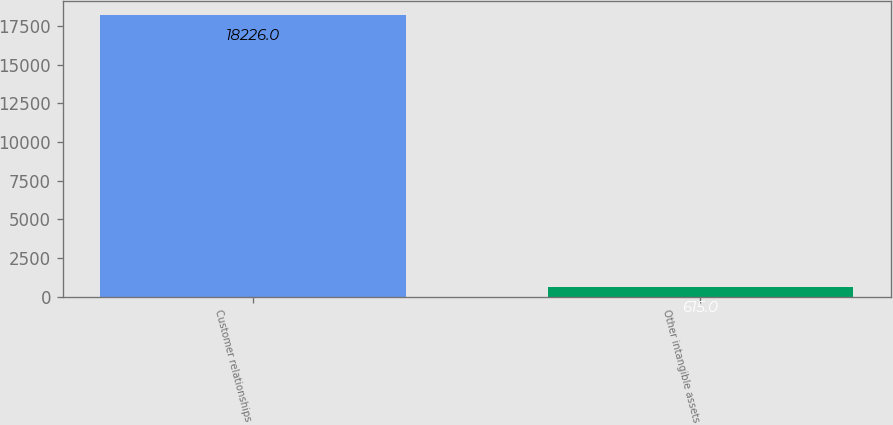<chart> <loc_0><loc_0><loc_500><loc_500><bar_chart><fcel>Customer relationships<fcel>Other intangible assets<nl><fcel>18226<fcel>615<nl></chart> 